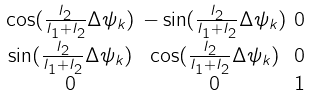Convert formula to latex. <formula><loc_0><loc_0><loc_500><loc_500>\begin{smallmatrix} \cos ( \frac { I _ { 2 } } { I _ { 1 } + I _ { 2 } } \Delta \psi _ { k } ) & - \sin ( \frac { I _ { 2 } } { I _ { 1 } + I _ { 2 } } \Delta \psi _ { k } ) & 0 \\ \sin ( \frac { I _ { 2 } } { I _ { 1 } + I _ { 2 } } \Delta \psi _ { k } ) & \cos ( \frac { I _ { 2 } } { I _ { 1 } + I _ { 2 } } \Delta \psi _ { k } ) & 0 \\ 0 & 0 & 1 \end{smallmatrix}</formula> 